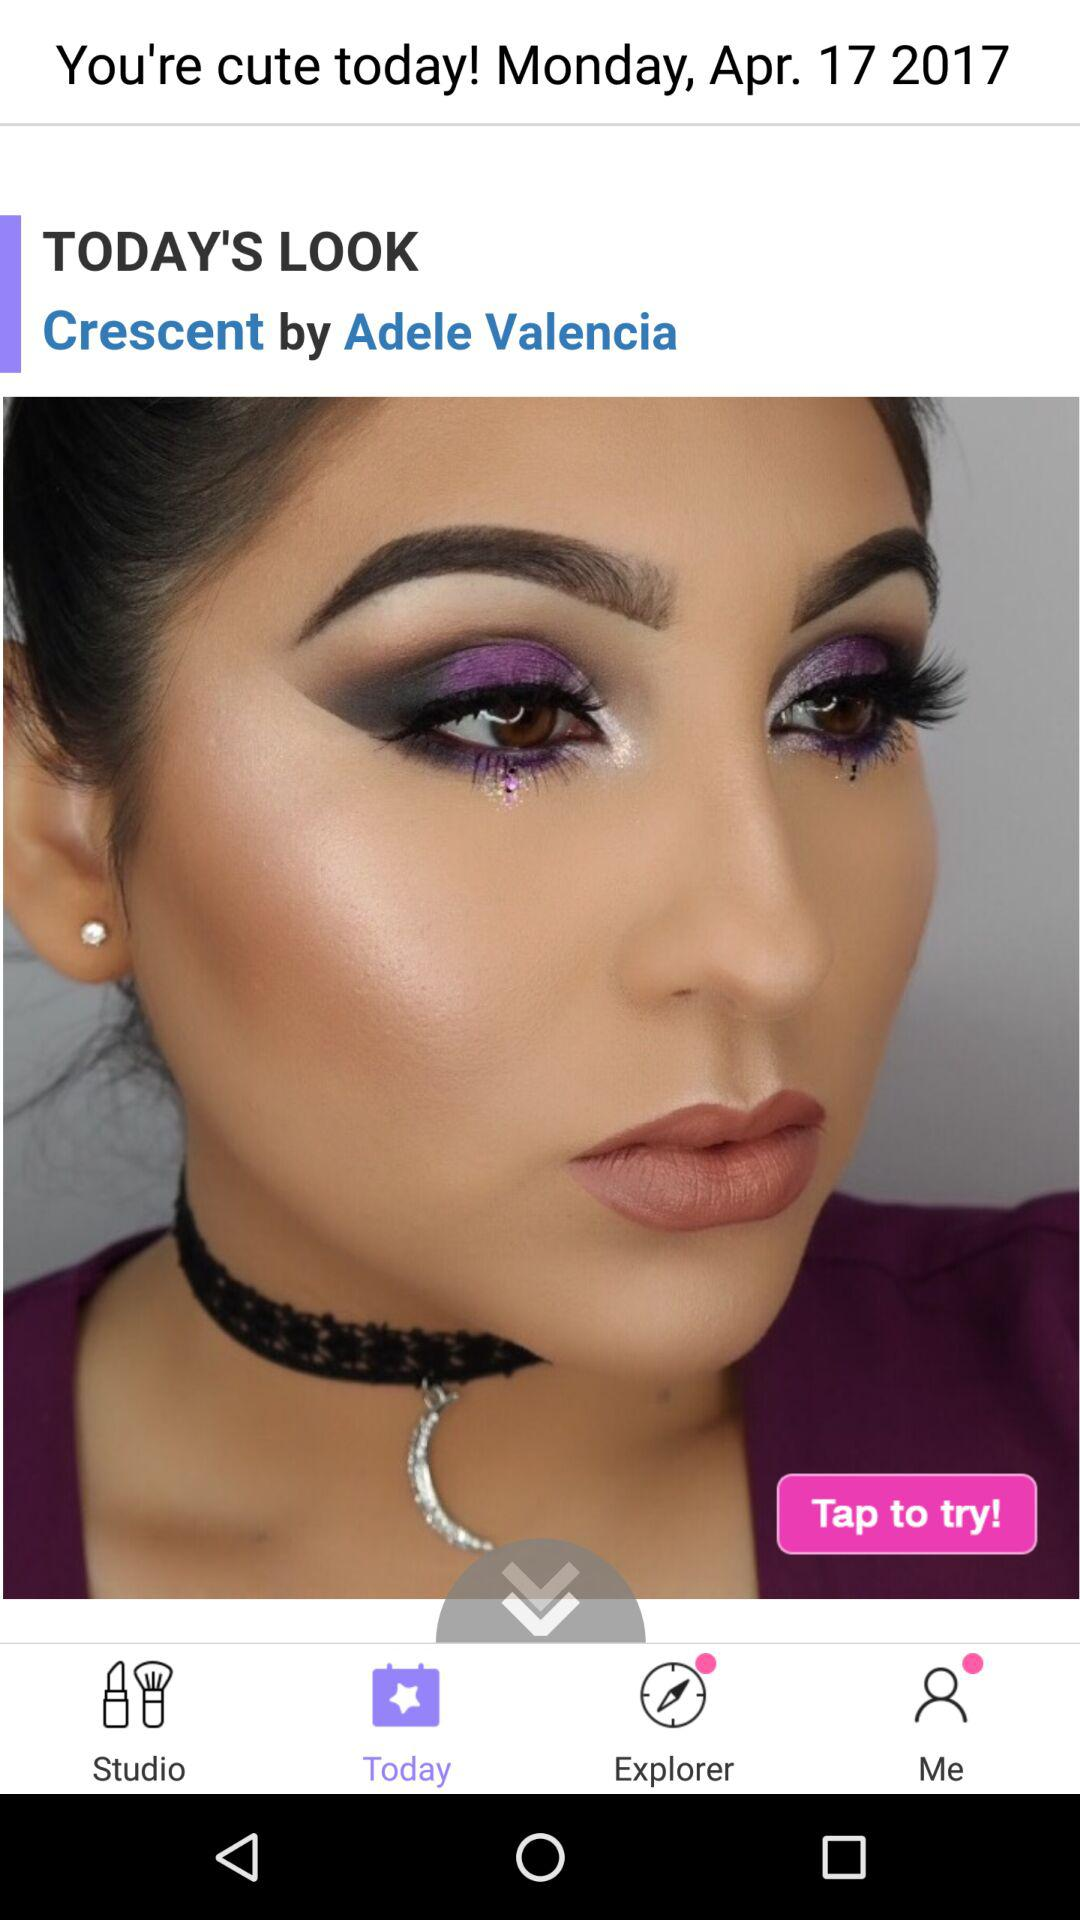What is the date of makeup? The date of makeup is Monday, April 17, 2017. 